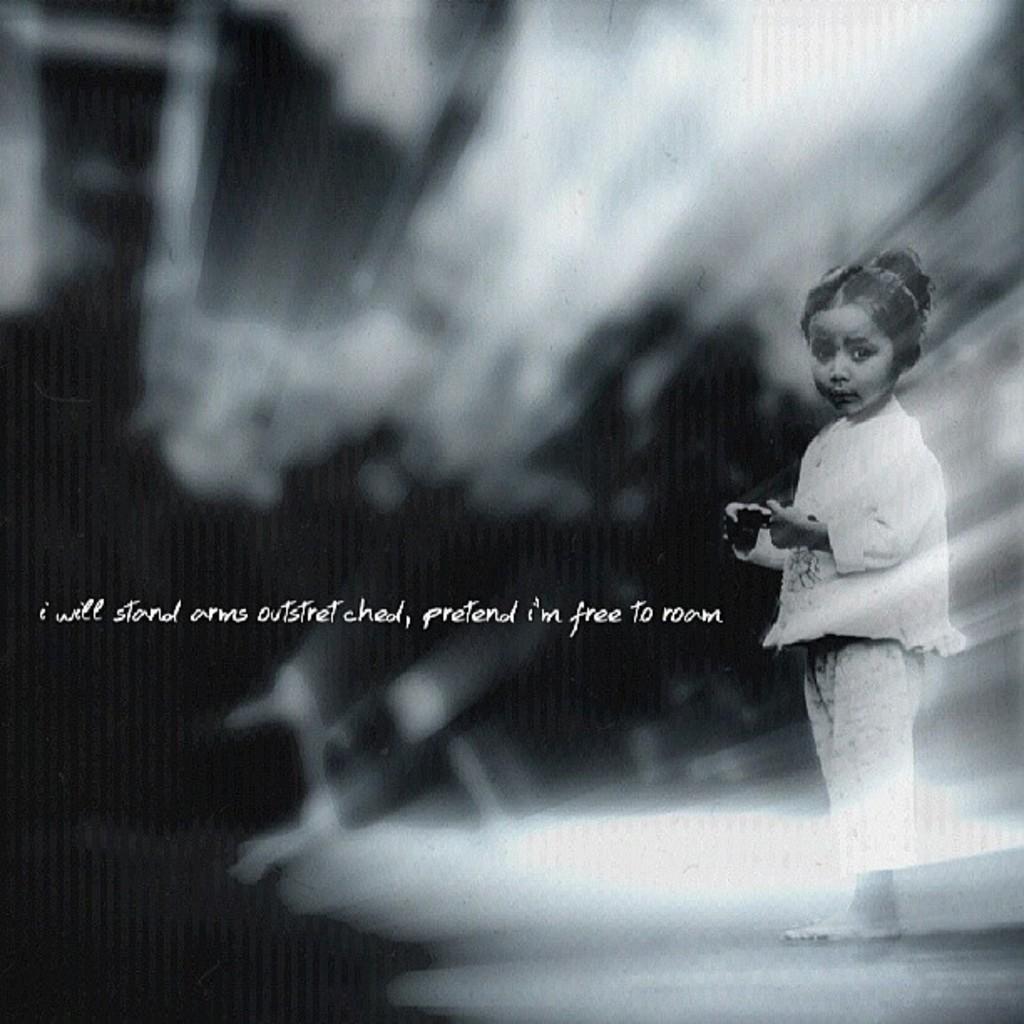How would you summarize this image in a sentence or two? I see this is a black and white image and I see a girl over here and I see few words written over here. 